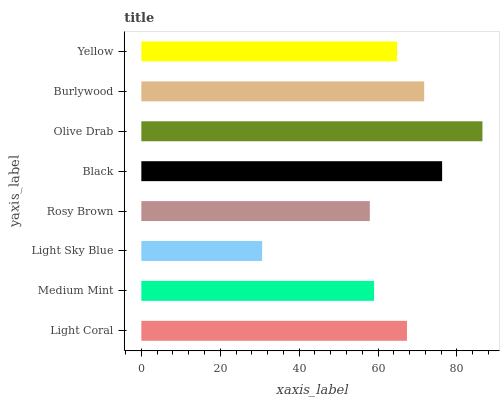Is Light Sky Blue the minimum?
Answer yes or no. Yes. Is Olive Drab the maximum?
Answer yes or no. Yes. Is Medium Mint the minimum?
Answer yes or no. No. Is Medium Mint the maximum?
Answer yes or no. No. Is Light Coral greater than Medium Mint?
Answer yes or no. Yes. Is Medium Mint less than Light Coral?
Answer yes or no. Yes. Is Medium Mint greater than Light Coral?
Answer yes or no. No. Is Light Coral less than Medium Mint?
Answer yes or no. No. Is Light Coral the high median?
Answer yes or no. Yes. Is Yellow the low median?
Answer yes or no. Yes. Is Light Sky Blue the high median?
Answer yes or no. No. Is Olive Drab the low median?
Answer yes or no. No. 